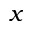<formula> <loc_0><loc_0><loc_500><loc_500>x</formula> 